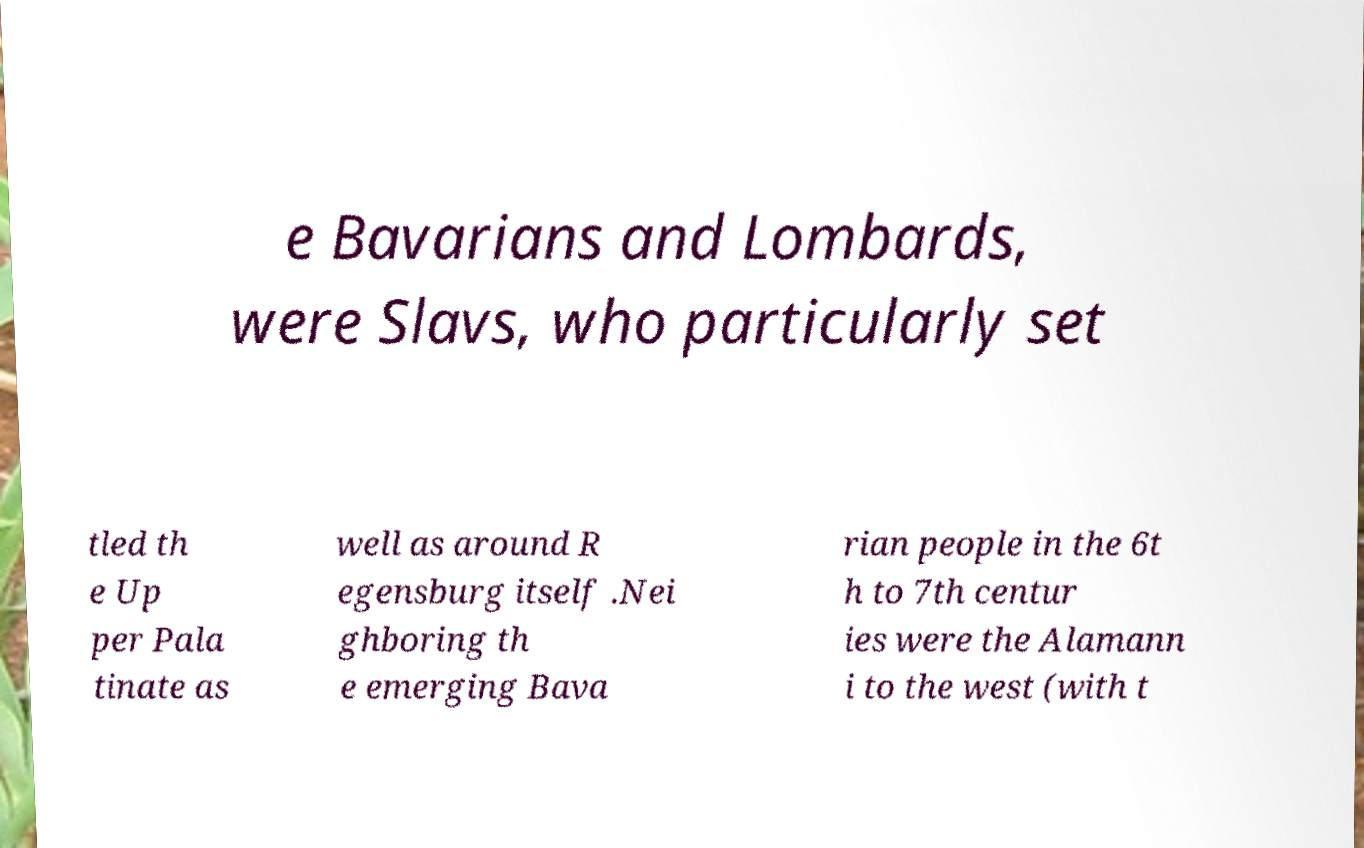Please identify and transcribe the text found in this image. e Bavarians and Lombards, were Slavs, who particularly set tled th e Up per Pala tinate as well as around R egensburg itself .Nei ghboring th e emerging Bava rian people in the 6t h to 7th centur ies were the Alamann i to the west (with t 